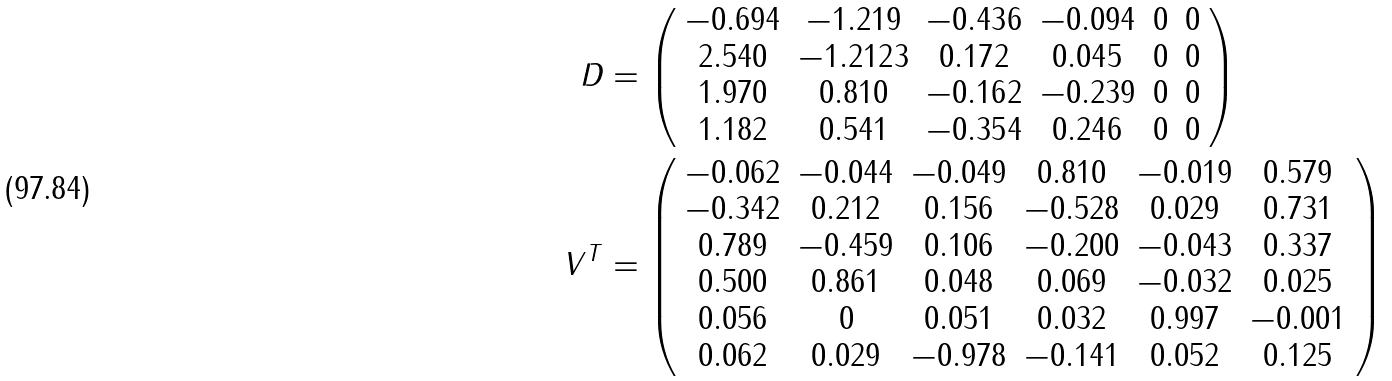Convert formula to latex. <formula><loc_0><loc_0><loc_500><loc_500>D & = \left ( \begin{array} { c c c c c c } - 0 . 6 9 4 & - 1 . 2 1 9 & - 0 . 4 3 6 & - 0 . 0 9 4 & 0 & 0 \\ 2 . 5 4 0 & - 1 . 2 1 2 3 & 0 . 1 7 2 & 0 . 0 4 5 & 0 & 0 \\ 1 . 9 7 0 & 0 . 8 1 0 & - 0 . 1 6 2 & - 0 . 2 3 9 & 0 & 0 \\ 1 . 1 8 2 & 0 . 5 4 1 & - 0 . 3 5 4 & 0 . 2 4 6 & 0 & 0 \end{array} \right ) \\ V ^ { T } & = \left ( \begin{array} { c c c c c c } - 0 . 0 6 2 & - 0 . 0 4 4 & - 0 . 0 4 9 & 0 . 8 1 0 & - 0 . 0 1 9 & 0 . 5 7 9 \\ - 0 . 3 4 2 & 0 . 2 1 2 & 0 . 1 5 6 & - 0 . 5 2 8 & 0 . 0 2 9 & 0 . 7 3 1 \\ 0 . 7 8 9 & - 0 . 4 5 9 & 0 . 1 0 6 & - 0 . 2 0 0 & - 0 . 0 4 3 & 0 . 3 3 7 \\ 0 . 5 0 0 & 0 . 8 6 1 & 0 . 0 4 8 & 0 . 0 6 9 & - 0 . 0 3 2 & 0 . 0 2 5 \\ 0 . 0 5 6 & 0 & 0 . 0 5 1 & 0 . 0 3 2 & 0 . 9 9 7 & - 0 . 0 0 1 \\ 0 . 0 6 2 & 0 . 0 2 9 & - 0 . 9 7 8 & - 0 . 1 4 1 & 0 . 0 5 2 & 0 . 1 2 5 \end{array} \right )</formula> 